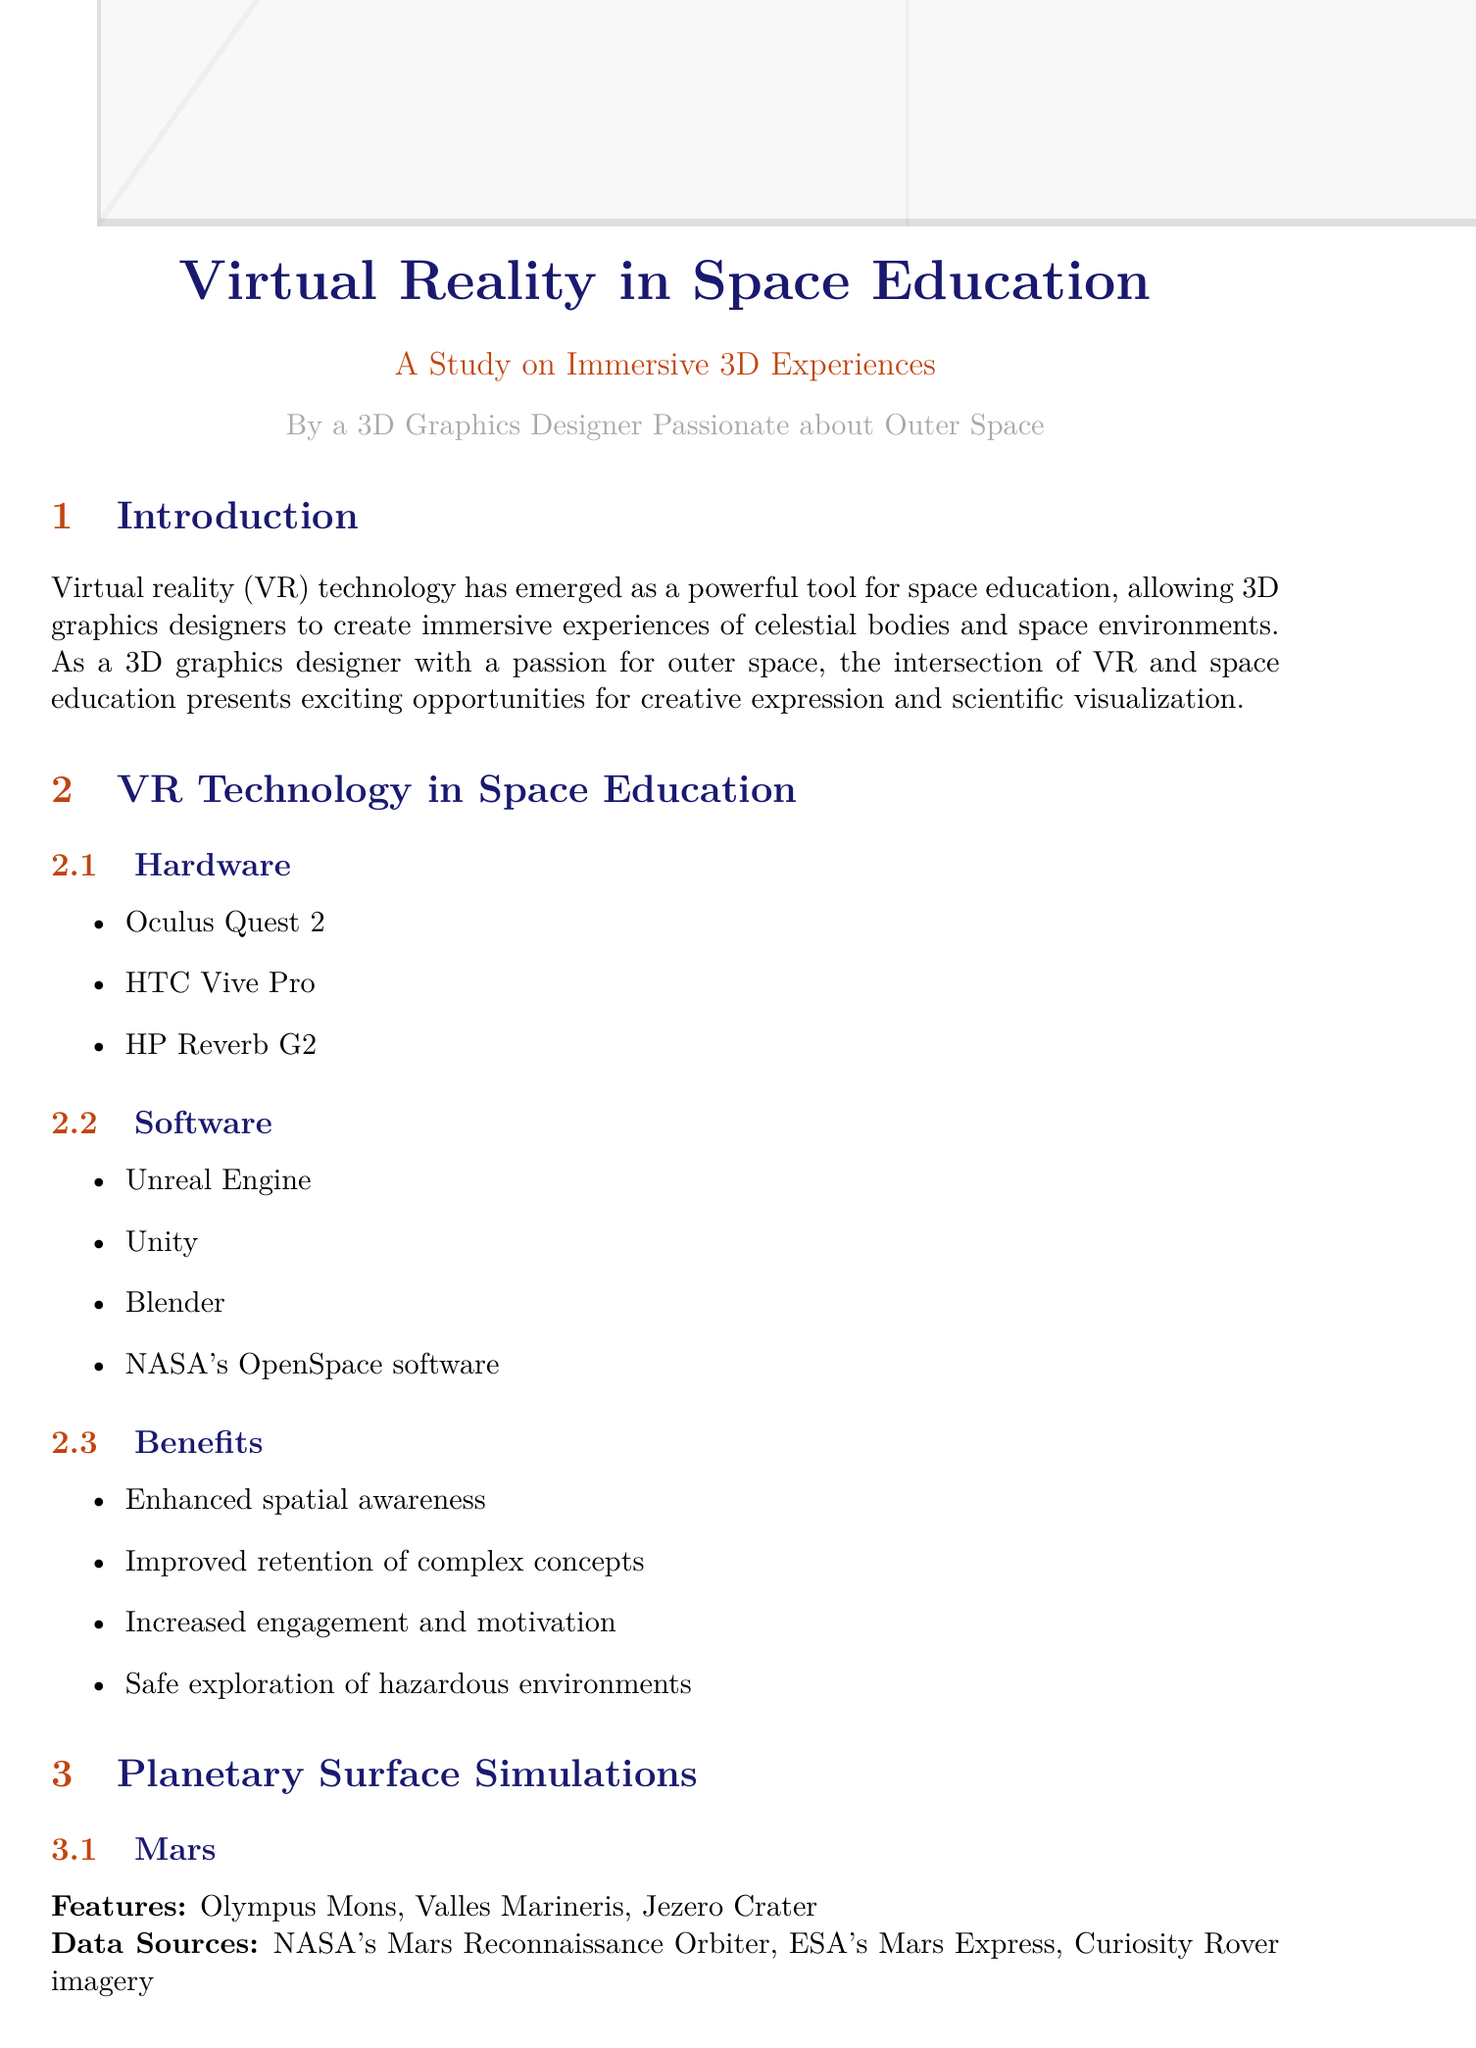What is a key benefit of VR in space education? The document lists several benefits, and one of them is improved retention of complex concepts.
Answer: Improved retention of complex concepts Which planetary surface features are highlighted for Mars? The document enumerates three features specifically related to Mars.
Answer: Olympus Mons, Valles Marineris, Jezero Crater What hardware is mentioned for VR space education? The document provides a list of VR hardware options, which includes Oculus Quest 2, HTC Vive Pro, and HP Reverb G2.
Answer: Oculus Quest 2 What type of activities are included in International Space Station simulations? The document mentions specific activities that are part of the simulations for the International Space Station.
Answer: Spacewalk training, Microgravity experiments, Earth observation What are two software options listed for creating VR experiences? The document proposes several software options, including Unreal Engine and Unity.
Answer: Unreal Engine, Unity How many data sources are listed for Venus surface simulations? The document specifies three data sources used for Venus simulations.
Answer: Three What is one challenge mentioned regarding accessibility in VR? The document points out specific challenges regarding accessibility, such as the cost of VR equipment for educational institutions.
Answer: Cost of VR equipment for educational institutions What future technology is mentioned for VR simulations? The document specifies future technological developments that include haptic feedback for simulated weightlessness.
Answer: Haptic feedback for simulated weightlessness 